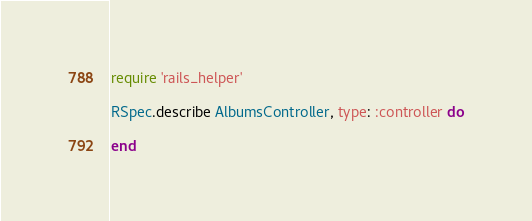<code> <loc_0><loc_0><loc_500><loc_500><_Ruby_>require 'rails_helper'

RSpec.describe AlbumsController, type: :controller do

end
</code> 